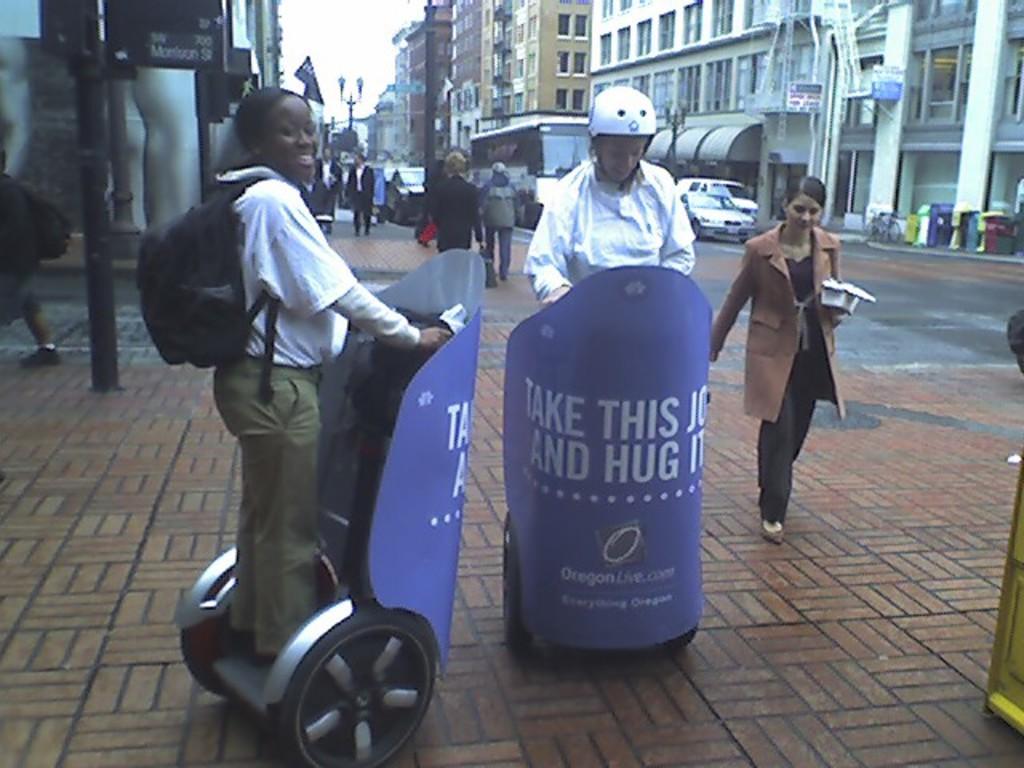Please provide a concise description of this image. In this image, we can see few people, vehicles, buildings, poles, boards and few objects. Here we can see two people are riding segways on the path. 